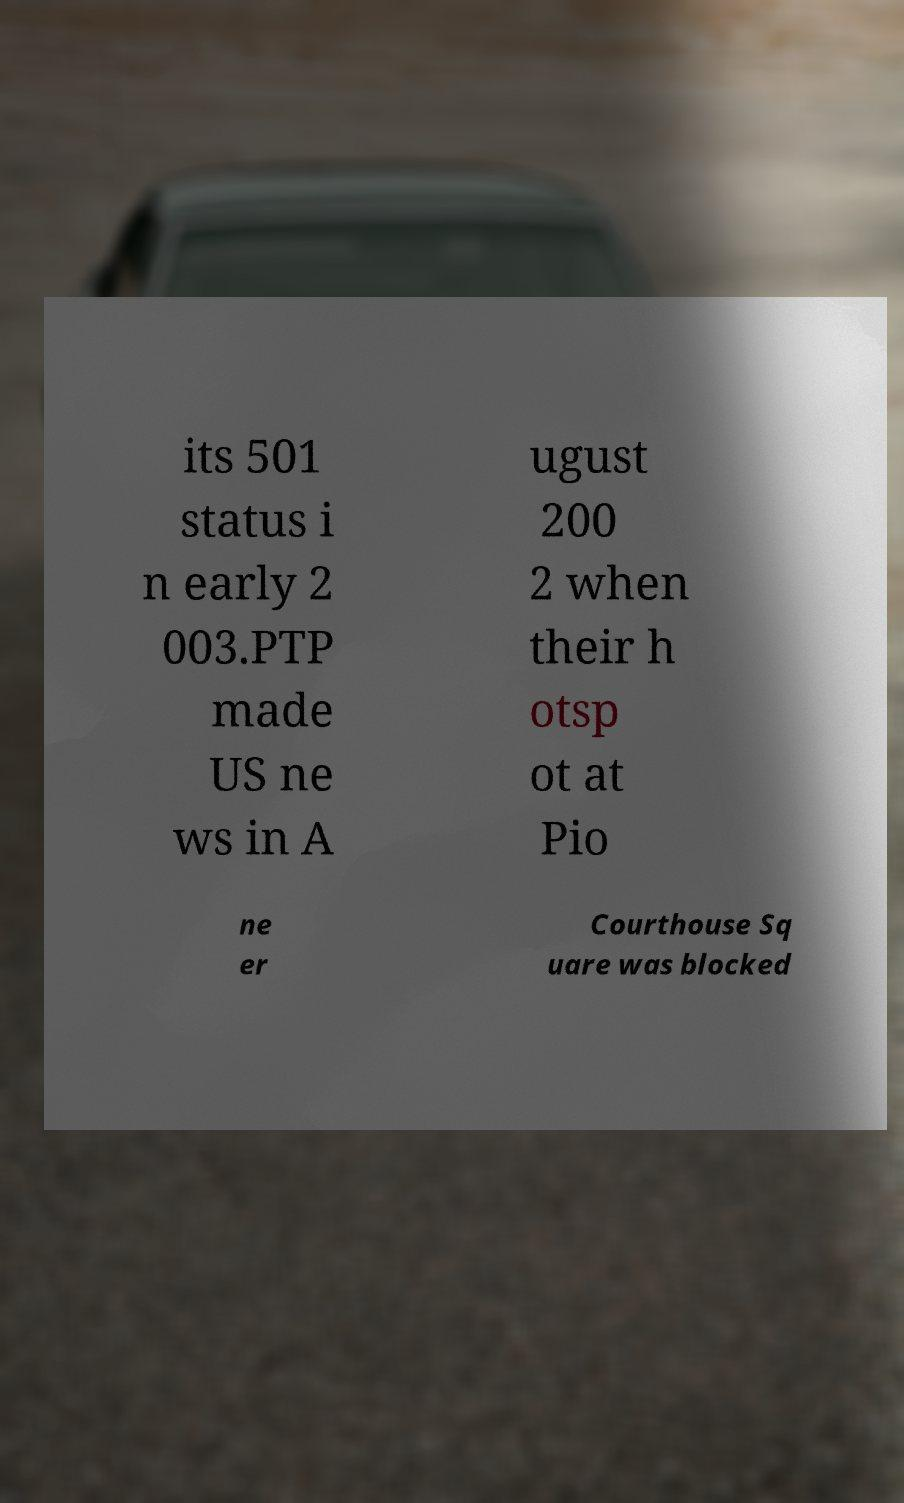What messages or text are displayed in this image? I need them in a readable, typed format. its 501 status i n early 2 003.PTP made US ne ws in A ugust 200 2 when their h otsp ot at Pio ne er Courthouse Sq uare was blocked 